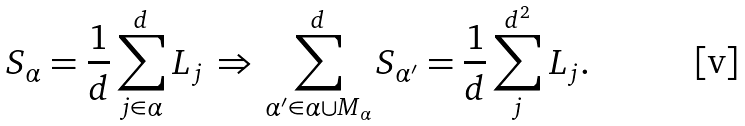<formula> <loc_0><loc_0><loc_500><loc_500>S _ { \alpha } = \frac { 1 } { d } \sum _ { j \in \alpha } ^ { d } L _ { j } \, \Rightarrow \, \sum _ { \alpha { ^ { \prime } } \in \alpha \cup M _ { \alpha } } ^ { d } S _ { \alpha { ^ { \prime } } } = \frac { 1 } { d } \sum _ { j } ^ { d ^ { 2 } } L _ { j } .</formula> 